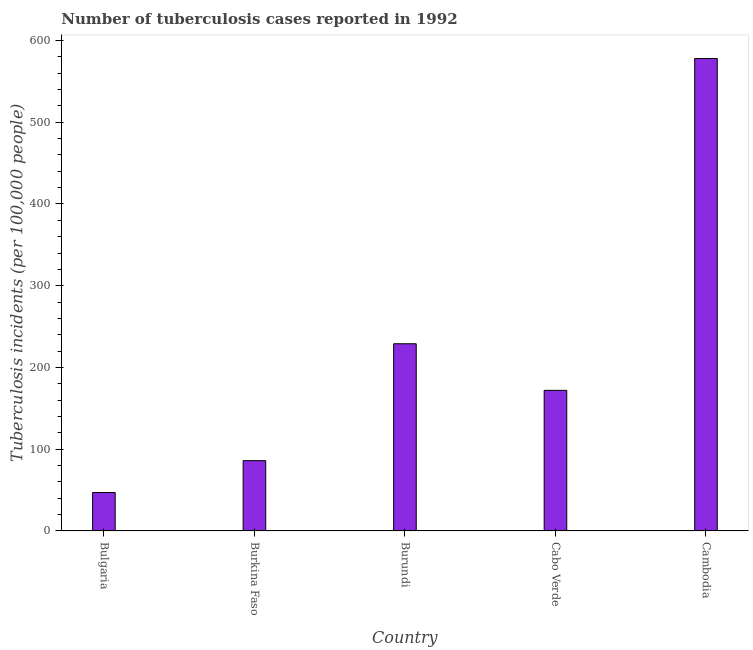Does the graph contain any zero values?
Provide a short and direct response. No. Does the graph contain grids?
Give a very brief answer. No. What is the title of the graph?
Offer a very short reply. Number of tuberculosis cases reported in 1992. What is the label or title of the X-axis?
Make the answer very short. Country. What is the label or title of the Y-axis?
Offer a very short reply. Tuberculosis incidents (per 100,0 people). What is the number of tuberculosis incidents in Bulgaria?
Make the answer very short. 47. Across all countries, what is the maximum number of tuberculosis incidents?
Your response must be concise. 578. In which country was the number of tuberculosis incidents maximum?
Ensure brevity in your answer.  Cambodia. What is the sum of the number of tuberculosis incidents?
Provide a succinct answer. 1112. What is the difference between the number of tuberculosis incidents in Burkina Faso and Cambodia?
Offer a very short reply. -492. What is the average number of tuberculosis incidents per country?
Make the answer very short. 222.4. What is the median number of tuberculosis incidents?
Offer a very short reply. 172. What is the difference between the highest and the second highest number of tuberculosis incidents?
Give a very brief answer. 349. Is the sum of the number of tuberculosis incidents in Cabo Verde and Cambodia greater than the maximum number of tuberculosis incidents across all countries?
Offer a terse response. Yes. What is the difference between the highest and the lowest number of tuberculosis incidents?
Offer a very short reply. 531. How many bars are there?
Your response must be concise. 5. Are all the bars in the graph horizontal?
Ensure brevity in your answer.  No. Are the values on the major ticks of Y-axis written in scientific E-notation?
Your response must be concise. No. What is the Tuberculosis incidents (per 100,000 people) in Bulgaria?
Offer a terse response. 47. What is the Tuberculosis incidents (per 100,000 people) in Burkina Faso?
Your response must be concise. 86. What is the Tuberculosis incidents (per 100,000 people) of Burundi?
Provide a succinct answer. 229. What is the Tuberculosis incidents (per 100,000 people) of Cabo Verde?
Your answer should be compact. 172. What is the Tuberculosis incidents (per 100,000 people) in Cambodia?
Your answer should be very brief. 578. What is the difference between the Tuberculosis incidents (per 100,000 people) in Bulgaria and Burkina Faso?
Give a very brief answer. -39. What is the difference between the Tuberculosis incidents (per 100,000 people) in Bulgaria and Burundi?
Your answer should be very brief. -182. What is the difference between the Tuberculosis incidents (per 100,000 people) in Bulgaria and Cabo Verde?
Ensure brevity in your answer.  -125. What is the difference between the Tuberculosis incidents (per 100,000 people) in Bulgaria and Cambodia?
Offer a very short reply. -531. What is the difference between the Tuberculosis incidents (per 100,000 people) in Burkina Faso and Burundi?
Make the answer very short. -143. What is the difference between the Tuberculosis incidents (per 100,000 people) in Burkina Faso and Cabo Verde?
Your response must be concise. -86. What is the difference between the Tuberculosis incidents (per 100,000 people) in Burkina Faso and Cambodia?
Your response must be concise. -492. What is the difference between the Tuberculosis incidents (per 100,000 people) in Burundi and Cambodia?
Provide a short and direct response. -349. What is the difference between the Tuberculosis incidents (per 100,000 people) in Cabo Verde and Cambodia?
Offer a very short reply. -406. What is the ratio of the Tuberculosis incidents (per 100,000 people) in Bulgaria to that in Burkina Faso?
Provide a short and direct response. 0.55. What is the ratio of the Tuberculosis incidents (per 100,000 people) in Bulgaria to that in Burundi?
Offer a very short reply. 0.2. What is the ratio of the Tuberculosis incidents (per 100,000 people) in Bulgaria to that in Cabo Verde?
Your response must be concise. 0.27. What is the ratio of the Tuberculosis incidents (per 100,000 people) in Bulgaria to that in Cambodia?
Offer a terse response. 0.08. What is the ratio of the Tuberculosis incidents (per 100,000 people) in Burkina Faso to that in Burundi?
Make the answer very short. 0.38. What is the ratio of the Tuberculosis incidents (per 100,000 people) in Burkina Faso to that in Cambodia?
Provide a succinct answer. 0.15. What is the ratio of the Tuberculosis incidents (per 100,000 people) in Burundi to that in Cabo Verde?
Keep it short and to the point. 1.33. What is the ratio of the Tuberculosis incidents (per 100,000 people) in Burundi to that in Cambodia?
Ensure brevity in your answer.  0.4. What is the ratio of the Tuberculosis incidents (per 100,000 people) in Cabo Verde to that in Cambodia?
Provide a succinct answer. 0.3. 